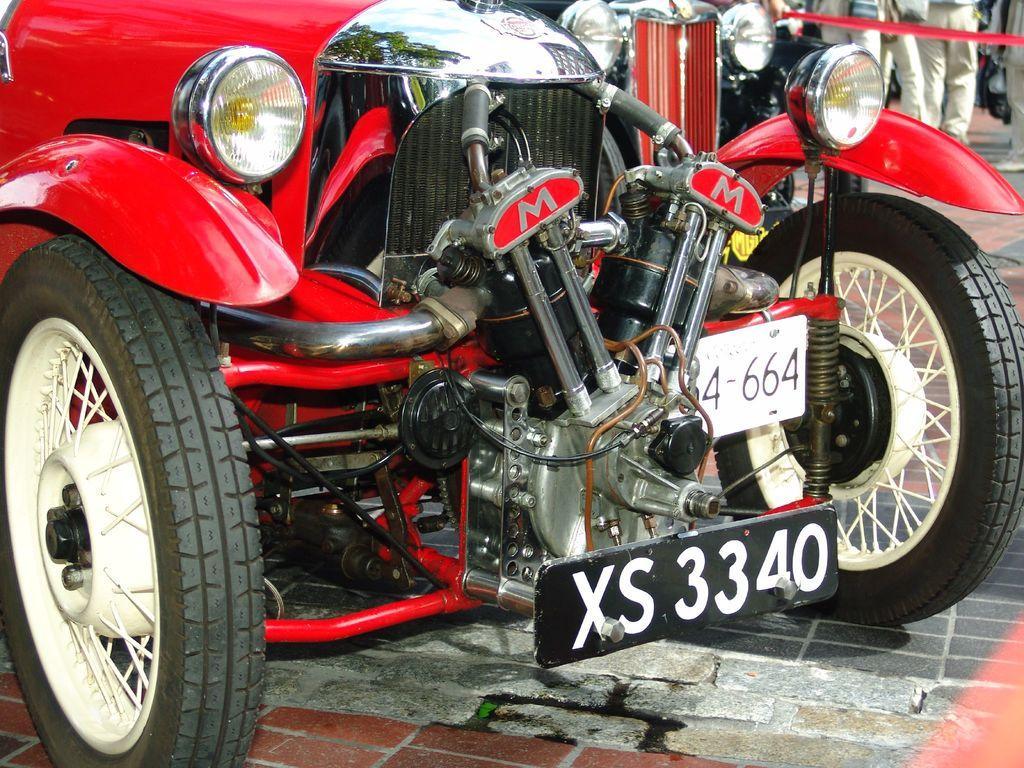Could you give a brief overview of what you see in this image? In the picture we can see a vintage car parked on the path which is red in color and besides to it, we can see another car and some people standing near them. 